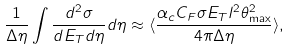Convert formula to latex. <formula><loc_0><loc_0><loc_500><loc_500>\frac { 1 } { \Delta \eta } \int \frac { d ^ { 2 } \sigma } { d E _ { T } d \eta } d \eta \approx \langle \frac { \alpha _ { c } C _ { F } \sigma E _ { T } l ^ { 2 } \theta _ { \max } ^ { 2 } } { 4 \pi \Delta \eta } \rangle ,</formula> 